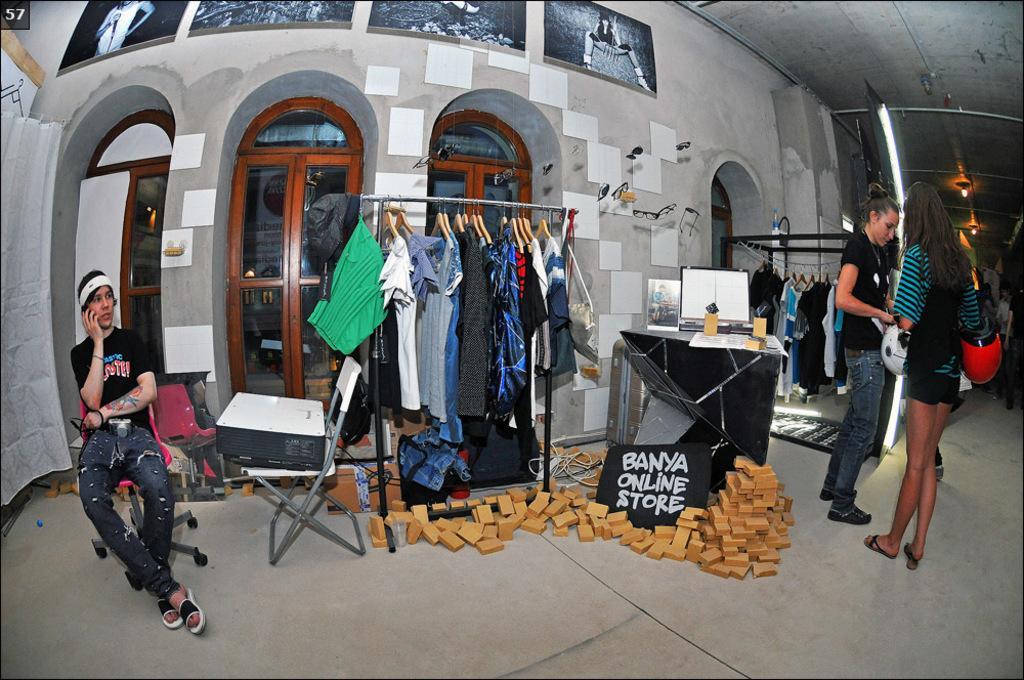Please provide a concise description of this image. In this picture I can see a man sitting on the chair, there is a camera, there are group of people standing, there are helmets, there are wooden blocks, there is an object on the chair, there is a monitor and some other items on the table, there is a board, there are clothes hanging to the clothes hangers , and in the background there are lights , frames attached to the wall and some other items. 